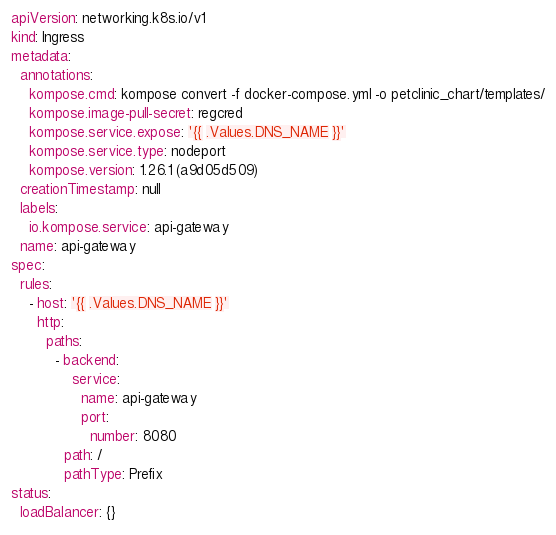Convert code to text. <code><loc_0><loc_0><loc_500><loc_500><_YAML_>apiVersion: networking.k8s.io/v1
kind: Ingress
metadata:
  annotations:
    kompose.cmd: kompose convert -f docker-compose.yml -o petclinic_chart/templates/
    kompose.image-pull-secret: regcred
    kompose.service.expose: '{{ .Values.DNS_NAME }}'
    kompose.service.type: nodeport
    kompose.version: 1.26.1 (a9d05d509)
  creationTimestamp: null
  labels:
    io.kompose.service: api-gateway
  name: api-gateway
spec:
  rules:
    - host: '{{ .Values.DNS_NAME }}'
      http:
        paths:
          - backend:
              service:
                name: api-gateway
                port:
                  number: 8080
            path: /
            pathType: Prefix
status:
  loadBalancer: {}
</code> 